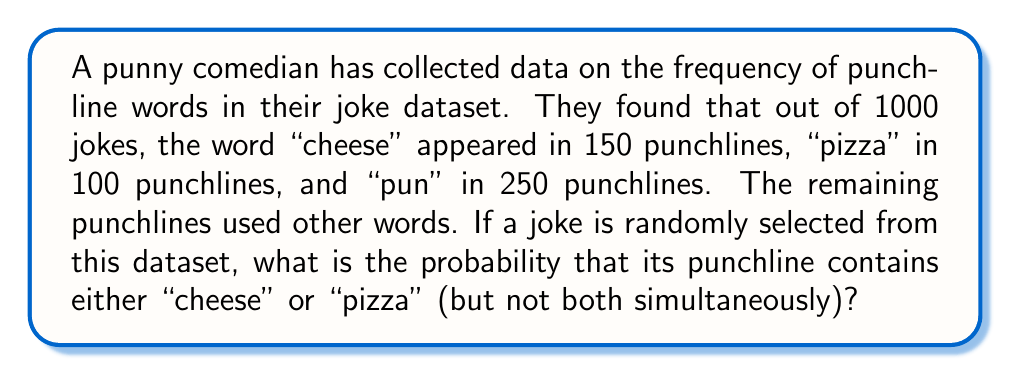Could you help me with this problem? Let's approach this step-by-step:

1) First, let's define our events:
   A: punchline contains "cheese"
   B: punchline contains "pizza"

2) We're asked to find P(A or B, but not both). This can be expressed as:
   P(A ∪ B) - P(A ∩ B)

3) We know:
   P(A) = 150/1000 = 0.15
   P(B) = 100/1000 = 0.10

4) To find P(A ∪ B), we can use the addition rule of probability:
   P(A ∪ B) = P(A) + P(B) - P(A ∩ B)

5) We don't know P(A ∩ B), but we can assume independence between the events (the presence of "cheese" doesn't affect the presence of "pizza" and vice versa). So:
   P(A ∩ B) = P(A) × P(B) = 0.15 × 0.10 = 0.015

6) Now we can calculate P(A ∪ B):
   P(A ∪ B) = 0.15 + 0.10 - 0.015 = 0.235

7) Therefore, the probability of a punchline containing either "cheese" or "pizza" (but not both) is:
   P(A ∪ B) - P(A ∩ B) = 0.235 - 0.015 = 0.22

8) To convert to a percentage: 0.22 × 100 = 22%

This result is quite cheesy, but it's no laughing matter when it comes to statistical accuracy!
Answer: The probability that a randomly selected joke's punchline contains either "cheese" or "pizza" (but not both) is 0.22 or 22%. 